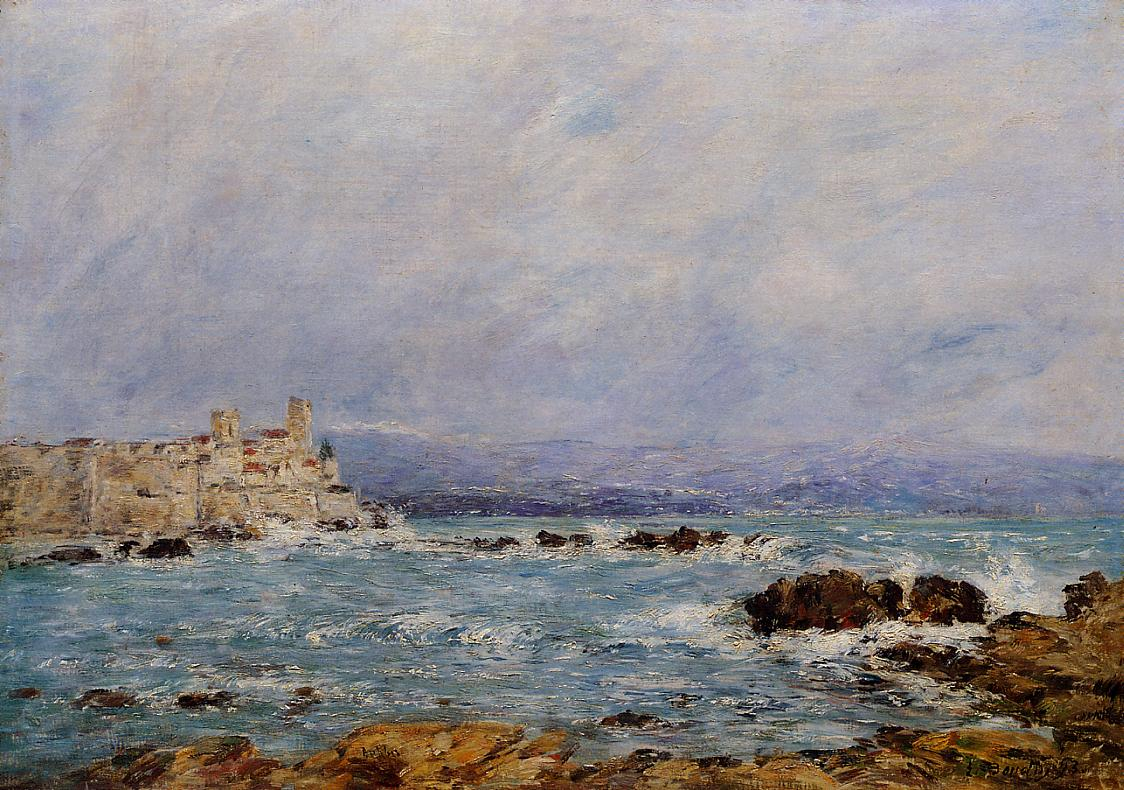Imagine the scene depicted here at different times of the day. At dawn, the sea might shimmer with the soft pink and orange hues of the rising sun, casting a warm glow on the castle and rocks. At midday, the bright blue sky and vivid sunlight would illuminate every detail, making the colors more vibrant. As twilight falls, the scene would be bathed in purples and oranges, with the castle silhouetted against the horizon. Under the moonlight, the entire landscape would transform into a serene and almost mystical place, illuminated by the gentle, silvery light. 